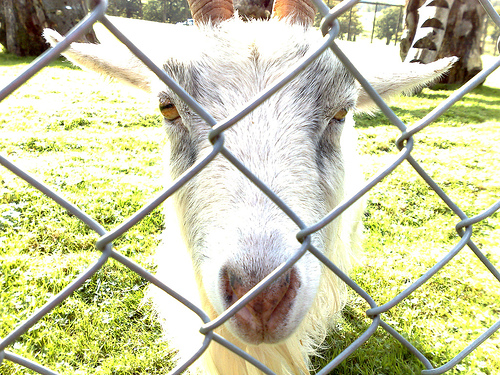<image>
Is there a goat behind the fence? Yes. From this viewpoint, the goat is positioned behind the fence, with the fence partially or fully occluding the goat. Where is the fence in relation to the goat? Is it behind the goat? No. The fence is not behind the goat. From this viewpoint, the fence appears to be positioned elsewhere in the scene. 